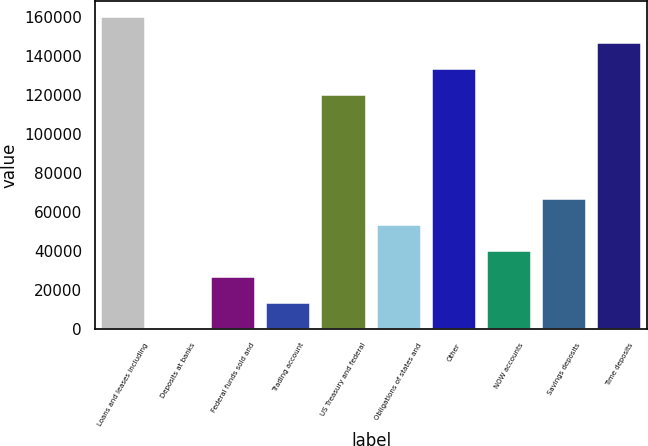Convert chart. <chart><loc_0><loc_0><loc_500><loc_500><bar_chart><fcel>Loans and leases including<fcel>Deposits at banks<fcel>Federal funds sold and<fcel>Trading account<fcel>US Treasury and federal<fcel>Obligations of states and<fcel>Other<fcel>NOW accounts<fcel>Savings deposits<fcel>Time deposits<nl><fcel>160186<fcel>15<fcel>26710.2<fcel>13362.6<fcel>120143<fcel>53405.4<fcel>133491<fcel>40057.8<fcel>66753<fcel>146839<nl></chart> 